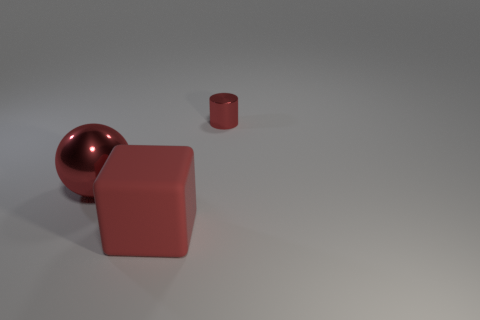Does the small cylinder have the same color as the rubber block?
Make the answer very short. Yes. What material is the big cube that is the same color as the sphere?
Make the answer very short. Rubber. Are there any other things of the same color as the tiny cylinder?
Provide a succinct answer. Yes. There is a object that is both in front of the tiny metallic thing and on the right side of the sphere; what is its material?
Offer a very short reply. Rubber. How many things are the same size as the red sphere?
Your answer should be compact. 1. What number of metallic objects are either large purple blocks or tiny red things?
Your response must be concise. 1. What is the tiny red thing made of?
Give a very brief answer. Metal. There is a cylinder; how many red matte cubes are behind it?
Your answer should be very brief. 0. Is the material of the big thing behind the large matte object the same as the tiny thing?
Your answer should be compact. Yes. How many tiny things are red metallic spheres or cylinders?
Offer a very short reply. 1. 